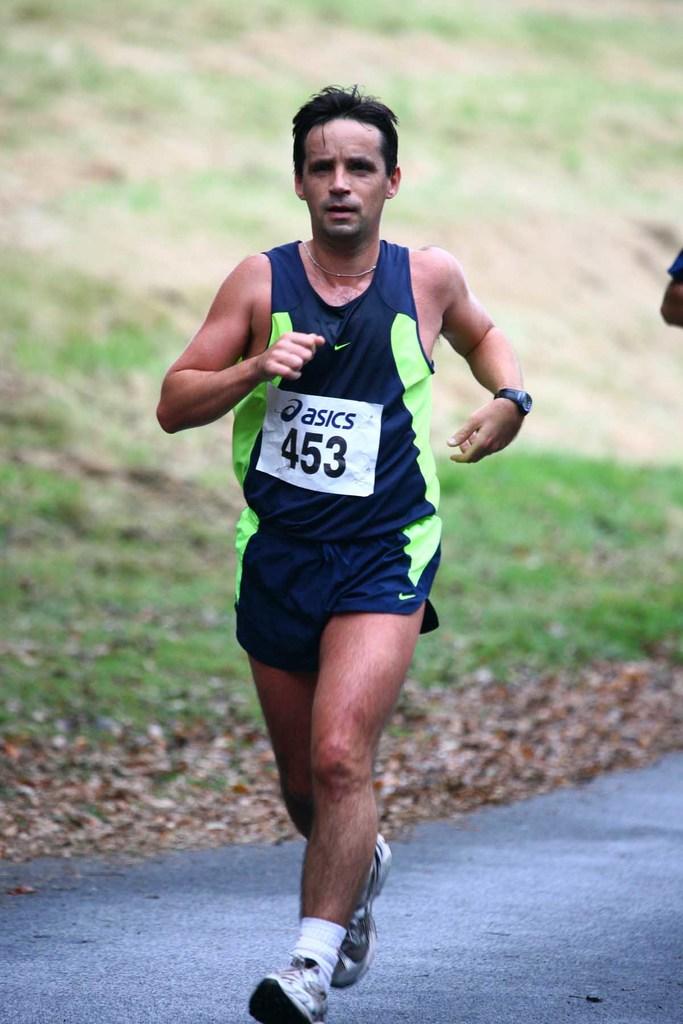Does it say asics on his sign?
Your response must be concise. Yes. 